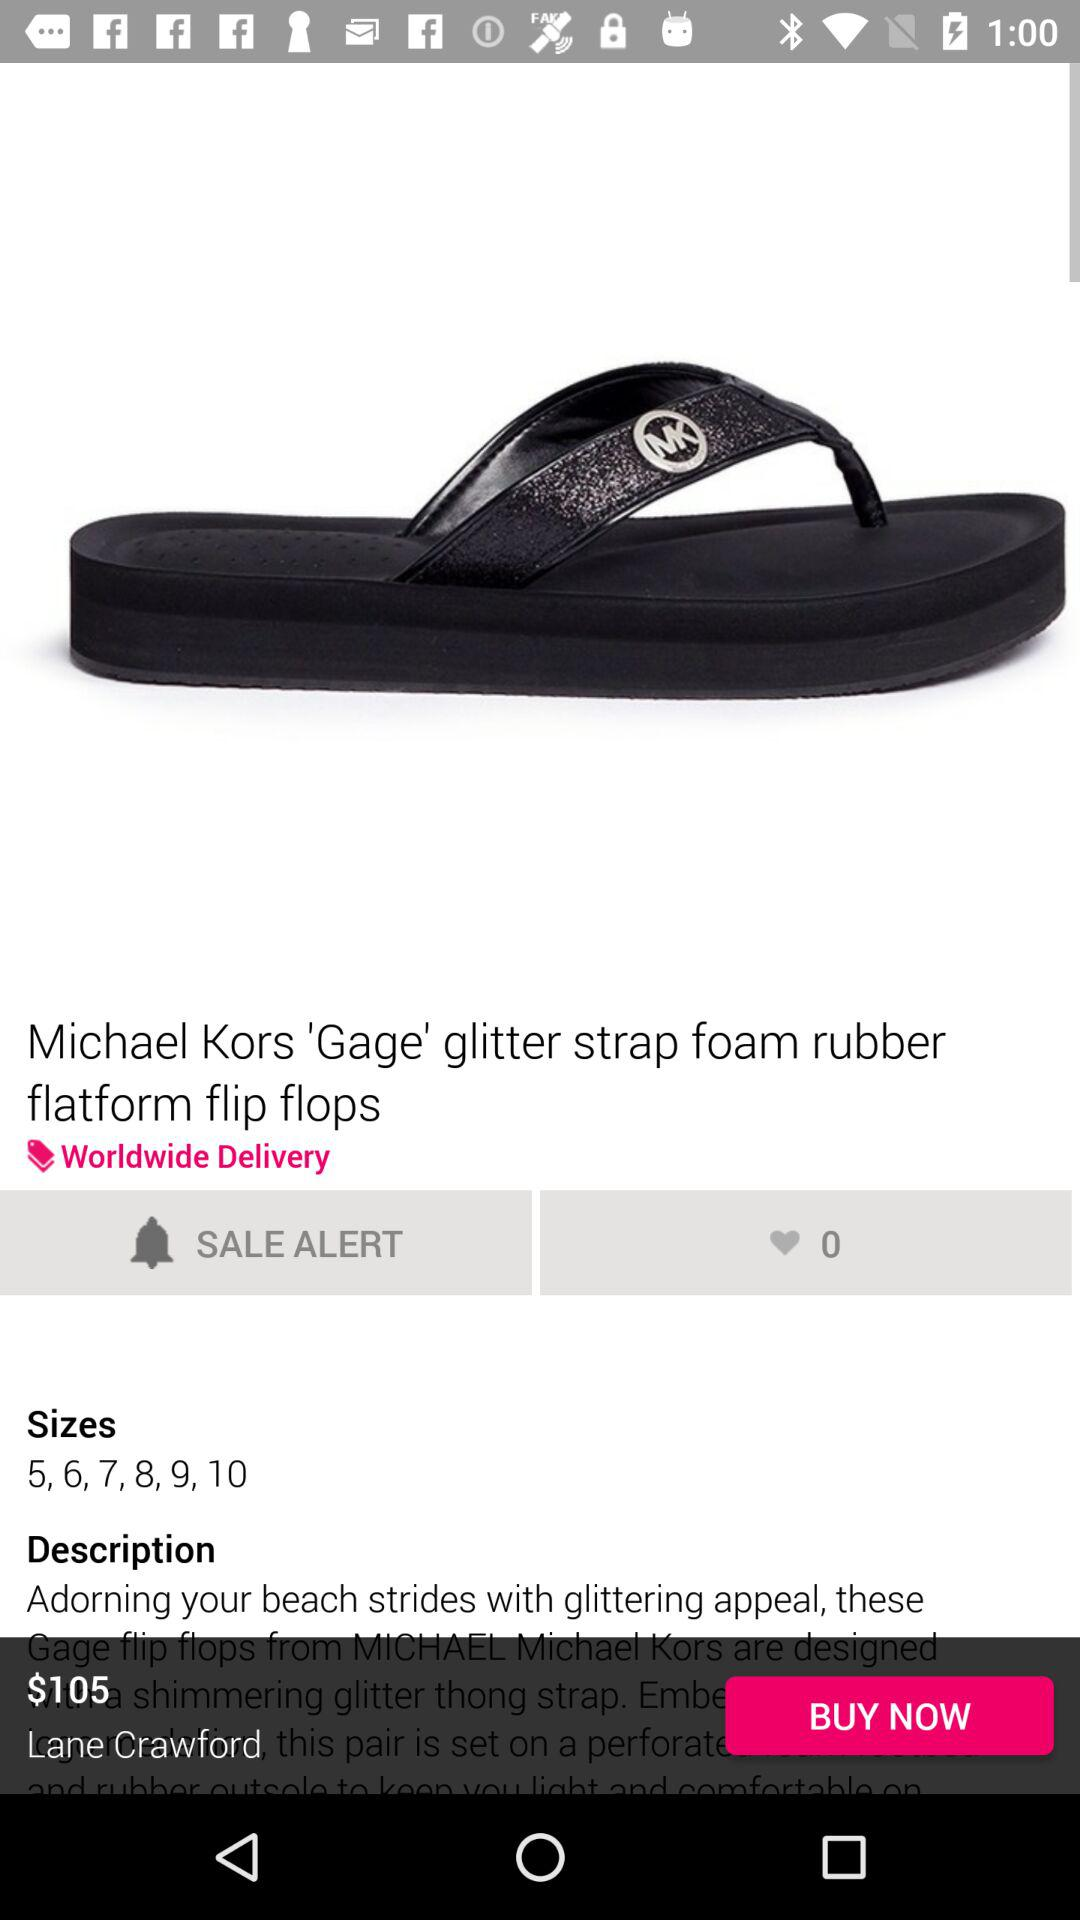What is the price of this "Michael Kors 'Gage' glitter strap foam rubber flatform flip flops"? The price is $105. 